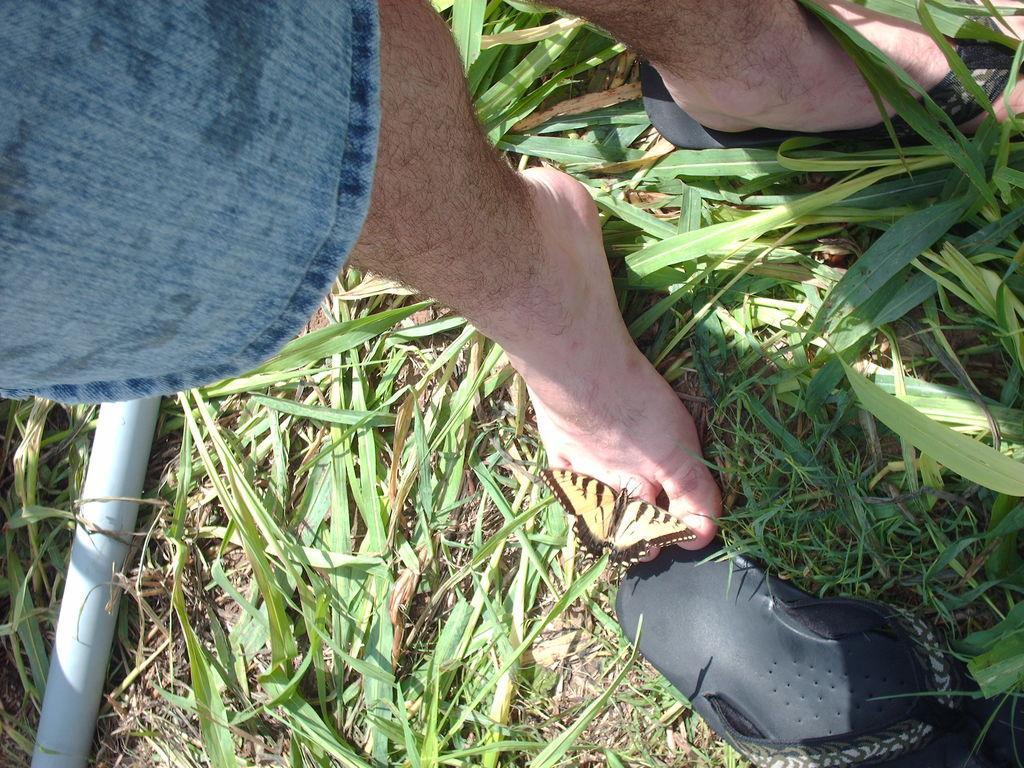Describe this image in one or two sentences. In this image I can see on the left side it looks like a pipe, on the right hand side bottom there is the slipper. In the middle there is a butterfly on the human leg. There is the grass, in the top left hand side there is the cloth. 